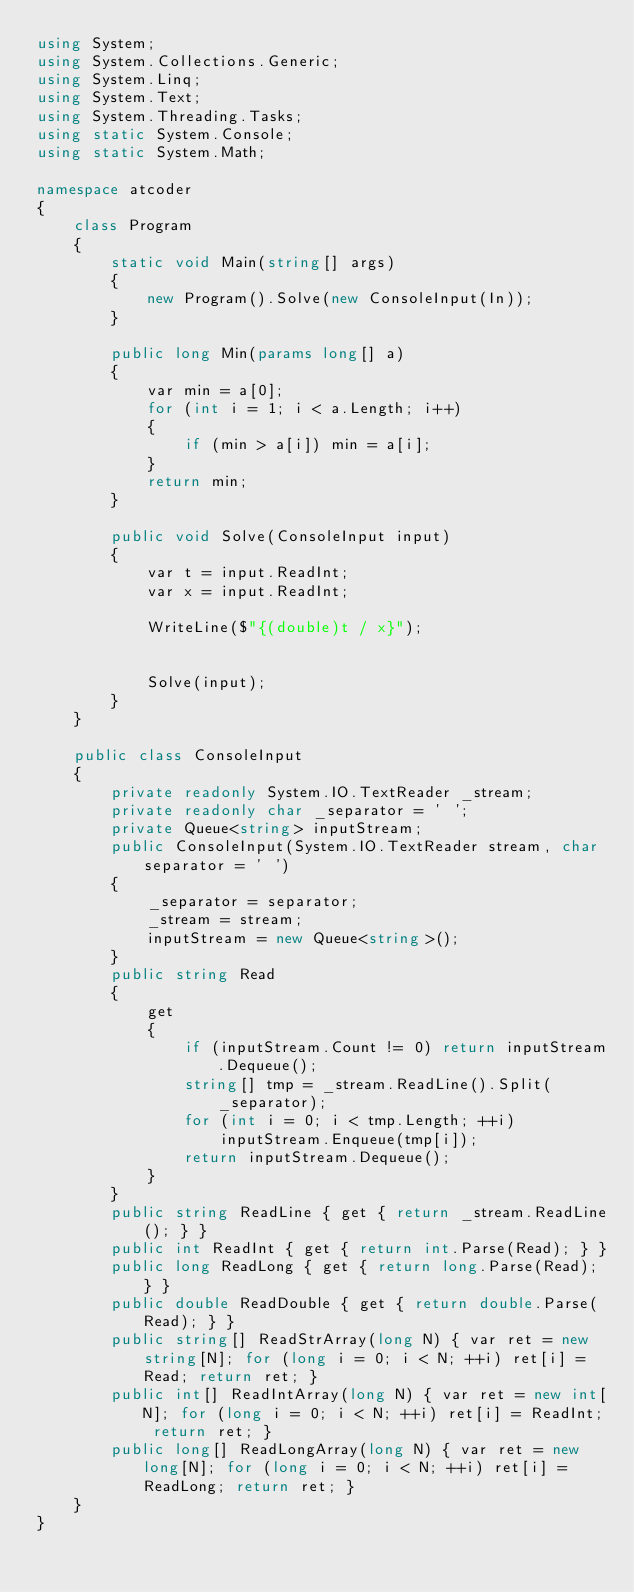Convert code to text. <code><loc_0><loc_0><loc_500><loc_500><_C#_>using System;
using System.Collections.Generic;
using System.Linq;
using System.Text;
using System.Threading.Tasks;
using static System.Console;
using static System.Math;

namespace atcoder
{
    class Program
    {
        static void Main(string[] args)
        {
            new Program().Solve(new ConsoleInput(In));
        }

        public long Min(params long[] a)
        {
            var min = a[0];
            for (int i = 1; i < a.Length; i++)
            {
                if (min > a[i]) min = a[i];
            }
            return min;
        }

        public void Solve(ConsoleInput input)
        {
            var t = input.ReadInt;
            var x = input.ReadInt;

            WriteLine($"{(double)t / x}");


            Solve(input);
        }
    }

    public class ConsoleInput
    {
        private readonly System.IO.TextReader _stream;
        private readonly char _separator = ' ';
        private Queue<string> inputStream;
        public ConsoleInput(System.IO.TextReader stream, char separator = ' ')
        {
            _separator = separator;
            _stream = stream;
            inputStream = new Queue<string>();
        }
        public string Read
        {
            get
            {
                if (inputStream.Count != 0) return inputStream.Dequeue();
                string[] tmp = _stream.ReadLine().Split(_separator);
                for (int i = 0; i < tmp.Length; ++i)
                    inputStream.Enqueue(tmp[i]);
                return inputStream.Dequeue();
            }
        }
        public string ReadLine { get { return _stream.ReadLine(); } }
        public int ReadInt { get { return int.Parse(Read); } }
        public long ReadLong { get { return long.Parse(Read); } }
        public double ReadDouble { get { return double.Parse(Read); } }
        public string[] ReadStrArray(long N) { var ret = new string[N]; for (long i = 0; i < N; ++i) ret[i] = Read; return ret; }
        public int[] ReadIntArray(long N) { var ret = new int[N]; for (long i = 0; i < N; ++i) ret[i] = ReadInt; return ret; }
        public long[] ReadLongArray(long N) { var ret = new long[N]; for (long i = 0; i < N; ++i) ret[i] = ReadLong; return ret; }
    }
}
</code> 